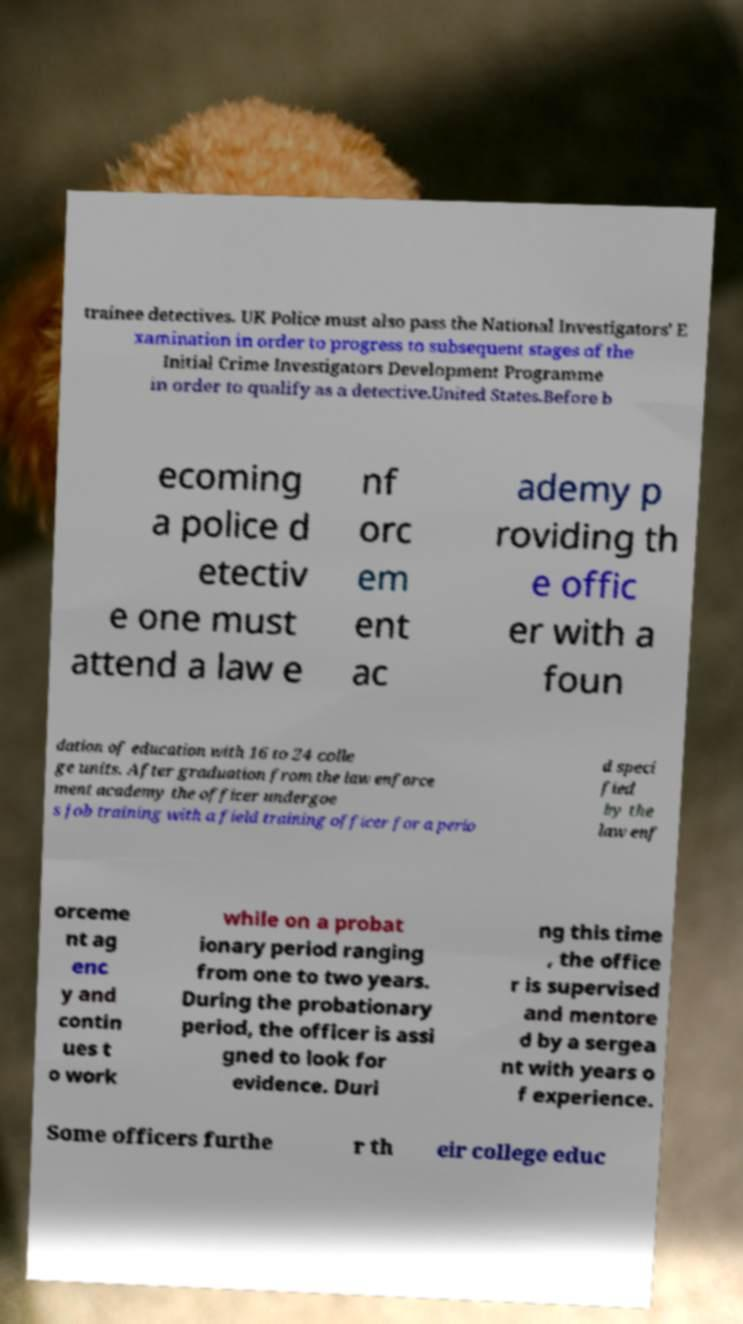Please read and relay the text visible in this image. What does it say? trainee detectives. UK Police must also pass the National Investigators' E xamination in order to progress to subsequent stages of the Initial Crime Investigators Development Programme in order to qualify as a detective.United States.Before b ecoming a police d etectiv e one must attend a law e nf orc em ent ac ademy p roviding th e offic er with a foun dation of education with 16 to 24 colle ge units. After graduation from the law enforce ment academy the officer undergoe s job training with a field training officer for a perio d speci fied by the law enf orceme nt ag enc y and contin ues t o work while on a probat ionary period ranging from one to two years. During the probationary period, the officer is assi gned to look for evidence. Duri ng this time , the office r is supervised and mentore d by a sergea nt with years o f experience. Some officers furthe r th eir college educ 